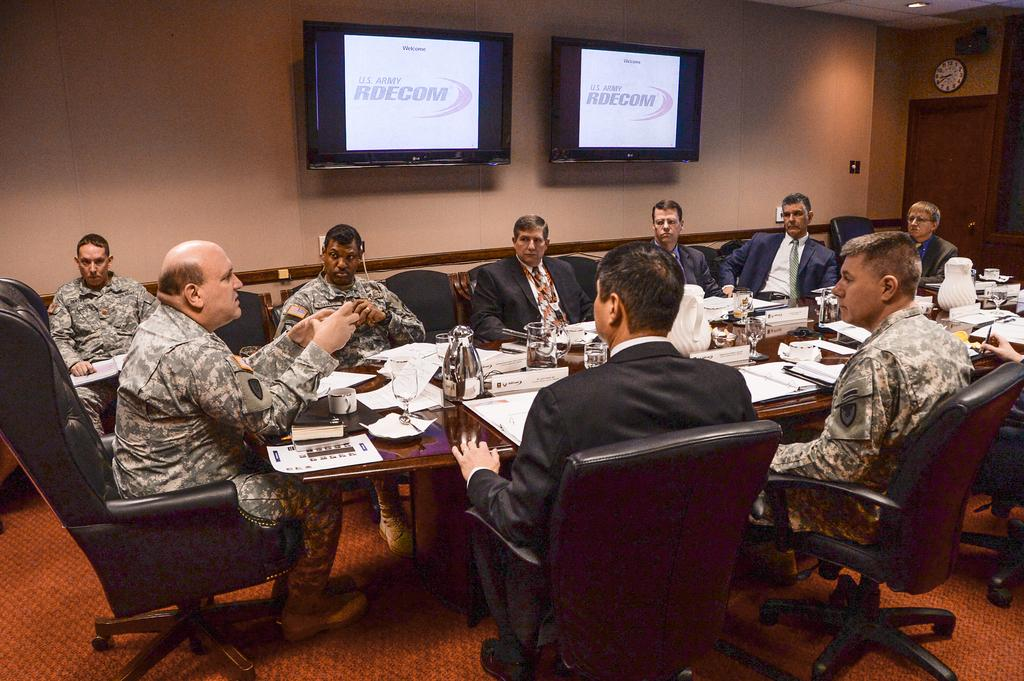What are the people in the image doing? The people in the image are sitting on chairs, which suggests they might be engaged in a meeting or conversation. Next, we describe the objects on the table, including glasses, jugs, a cup, and papers. We also mention the presence of a television and a clock on the wall, as well as a door in the image. Each question is designed to elicit a specific detail about the image that is known from the provided facts. Absurd Question/Answer: What type of brass stem can be seen on the locket in the image? There is no brass stem or locket present in the image. What type of brass stem can be seen on the locket in the image? There is no brass stem or locket present in the image. 